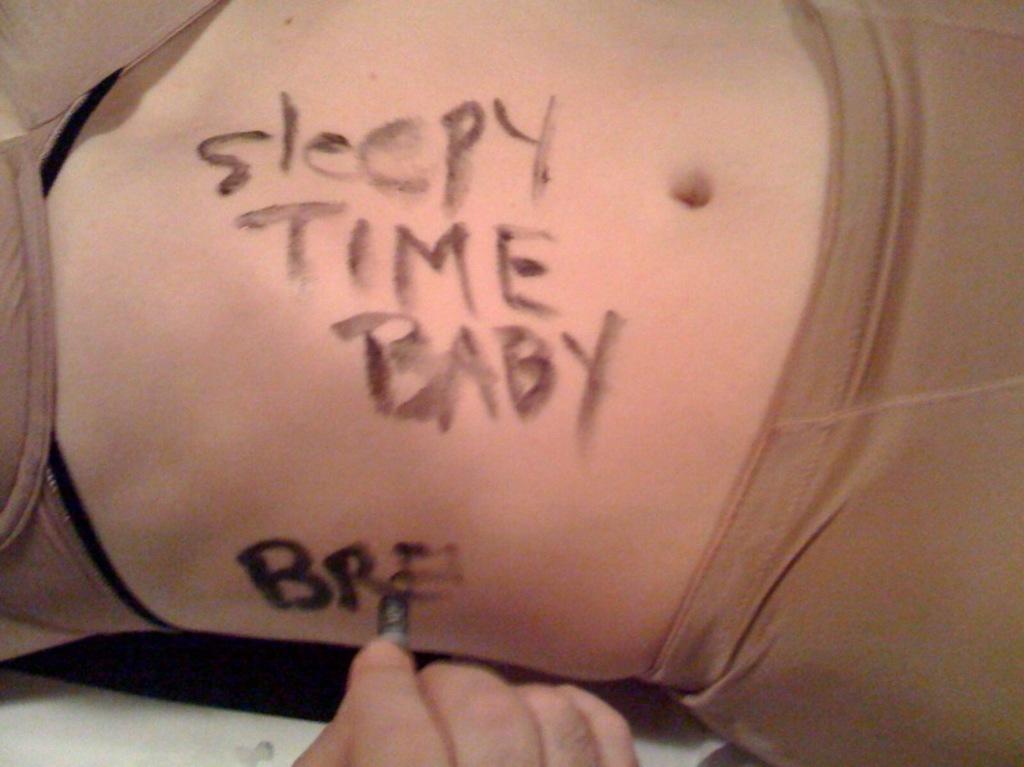Can you describe this image briefly? We can see a woman's stomach. On that something is written. Also we can see a person's hand and is writing something on the stomach. 